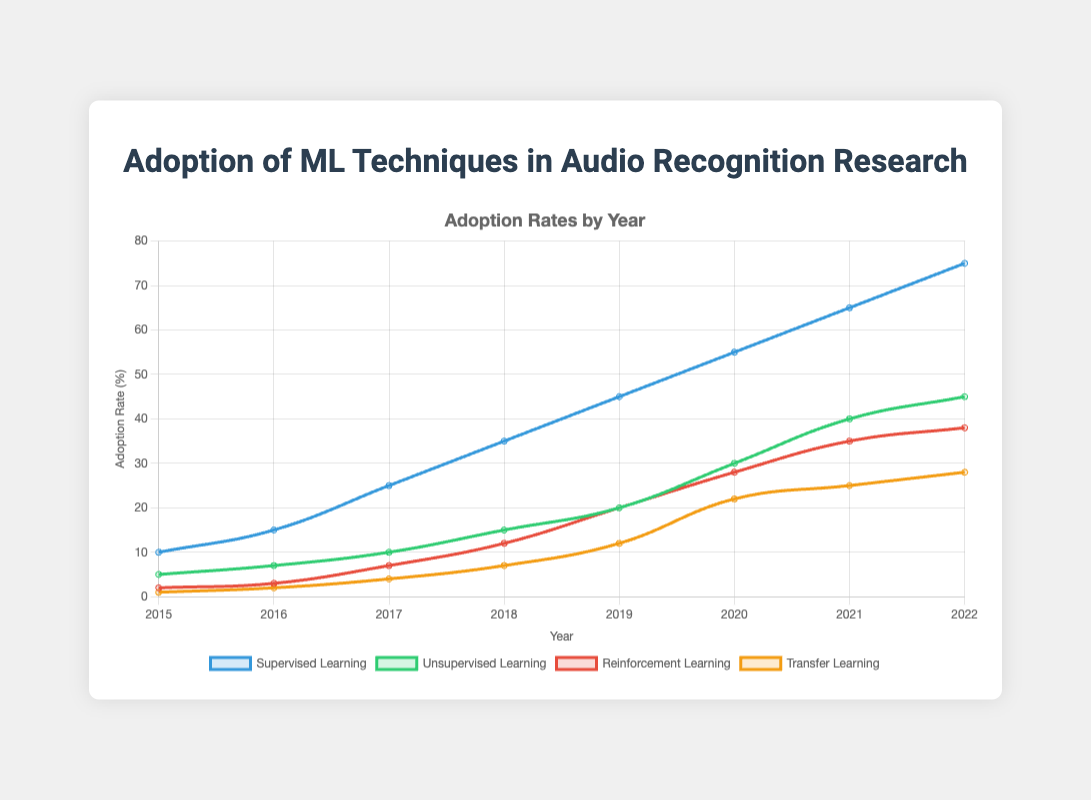What is the adoption rate of supervised learning in 2020? Look at the line corresponding to "Supervised Learning" and find the value at the year 2020. The value is 55%.
Answer: 55% Which machine learning technique had the greatest adoption rate in 2018? Find the highest value among the four techniques in 2018. Supervised Learning has the highest adoption rate with 35%.
Answer: Supervised Learning What is the average adoption rate of reinforcement learning from 2016 to 2018? Add the adoption rates of reinforcement learning for 2016, 2017, and 2018 (3 + 7 + 12), then divide by 3. Average = (3 + 7 + 12) / 3 = 22 / 3 = 7.33 (approx).
Answer: 7.33 Did unsupervised learning or transfer learning grow faster from 2015 to 2022? Compare the difference in adoption rates from 2015 to 2022 for both techniques. Unsupervised Learning grew from 5 to 45 (difference = 40), while Transfer Learning grew from 1 to 28 (difference = 27). Unsupervised Learning grew faster.
Answer: Unsupervised Learning What trend do you observe in the adoption rate of supervised learning over the years? Look at the line corresponding to supervised learning. It shows a consistent increase every year from 10% in 2015 to 75% in 2022.
Answer: Consistent increase What is the difference in adoption rates between reinforcement learning and unsupervised learning in 2022? Subtract the adoption rate of unsupervised learning from reinforcement learning in 2022. Difference = 38 - 45 = -7.
Answer: -7 Which technique had the lowest adoption rate in 2019? Find the smallest value among the four techniques in 2019. Transfer Learning has the lowest rate with 12%.
Answer: Transfer Learning What is the total adoption rate of all techniques in 2021? Add the adoption rates of all four techniques in 2021. Total = 65 (Supervised) + 40 (Unsupervised) + 35 (Reinforcement) + 25 (Transfer) = 165.
Answer: 165 How does the adoption rate of transfer learning in 2022 compare to its adoption rate in 2015? Compare the adoption rates in 2015 and 2022 for transfer learning. In 2015 it was 1%, and in 2022 it was 28%.
Answer: Increased by 27 